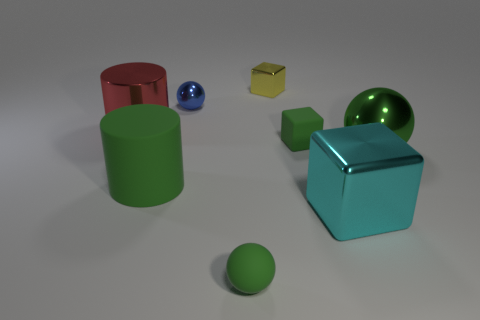Is the color of the small shiny cube the same as the big metallic block?
Give a very brief answer. No. How many things are either cyan metallic objects that are to the right of the large red thing or spheres?
Your answer should be compact. 4. What is the shape of the other metal object that is the same size as the blue object?
Your answer should be compact. Cube. Is the size of the block that is in front of the tiny matte block the same as the green matte thing behind the green matte cylinder?
Keep it short and to the point. No. There is a cylinder that is the same material as the large sphere; what color is it?
Your response must be concise. Red. Does the small green thing that is on the right side of the tiny yellow object have the same material as the green ball that is behind the cyan metallic block?
Your answer should be compact. No. Are there any blue balls of the same size as the cyan thing?
Offer a very short reply. No. How big is the green sphere that is right of the tiny green thing that is in front of the big green matte cylinder?
Your response must be concise. Large. How many tiny matte things have the same color as the tiny matte cube?
Your answer should be very brief. 1. There is a yellow metallic thing that is behind the green ball that is right of the small shiny cube; what is its shape?
Provide a short and direct response. Cube. 